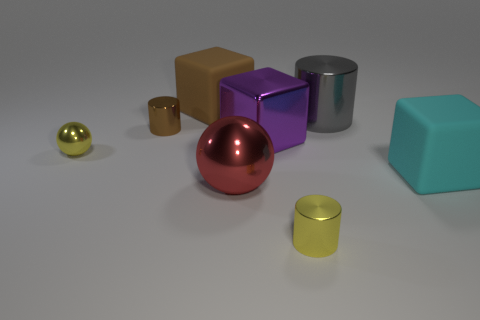What number of rubber things are there?
Your answer should be very brief. 2. Are the small cylinder that is to the right of the red metal sphere and the block behind the purple block made of the same material?
Ensure brevity in your answer.  No. The cube that is the same material as the large brown object is what size?
Provide a succinct answer. Large. The large rubber object that is to the right of the large brown thing has what shape?
Your response must be concise. Cube. There is a small metallic cylinder that is in front of the small yellow ball; is it the same color as the ball to the left of the big red sphere?
Provide a succinct answer. Yes. Is there a large purple rubber block?
Provide a succinct answer. No. There is a yellow metal thing that is to the left of the matte thing left of the cube that is in front of the large purple block; what is its shape?
Provide a succinct answer. Sphere. What number of metallic cylinders are in front of the big cyan cube?
Offer a terse response. 1. Is the material of the yellow object that is behind the big red metal thing the same as the purple block?
Your answer should be very brief. Yes. How many other things are there of the same shape as the big purple metal thing?
Make the answer very short. 2. 